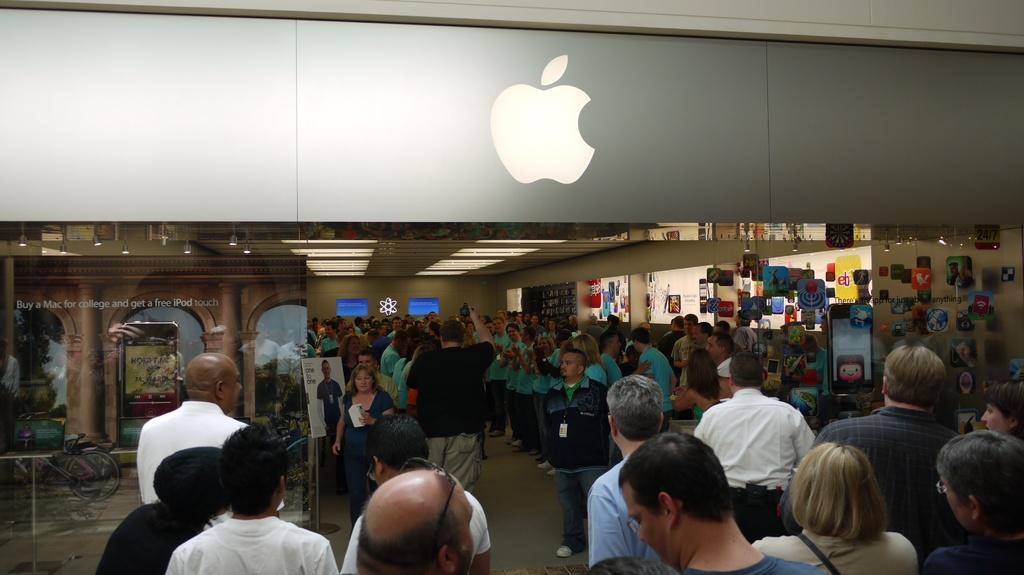What is the main subject of the image? The main subject of the image is a huge crowd in the showroom. What can be seen in the background of the image? There is a wall in the background of the image. What brand is associated with the showroom? The Apple logo at the entrance of the showroom indicates that it is an Apple store. What type of pie is being served to the crowd in the image? There is no pie present in the image; it features a crowd in an Apple store. Can you see any snakes slithering around in the image? There are no snakes present in the image. 